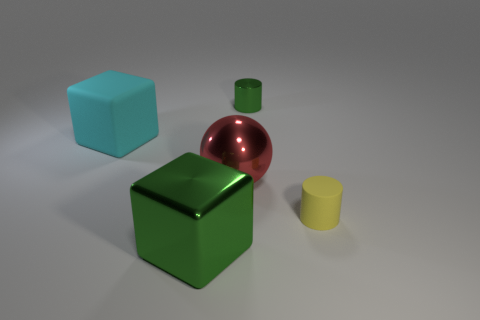Add 3 big green metal objects. How many objects exist? 8 Subtract all balls. How many objects are left? 4 Subtract 0 cyan cylinders. How many objects are left? 5 Subtract all rubber things. Subtract all big brown rubber cylinders. How many objects are left? 3 Add 2 small shiny objects. How many small shiny objects are left? 3 Add 3 green shiny things. How many green shiny things exist? 5 